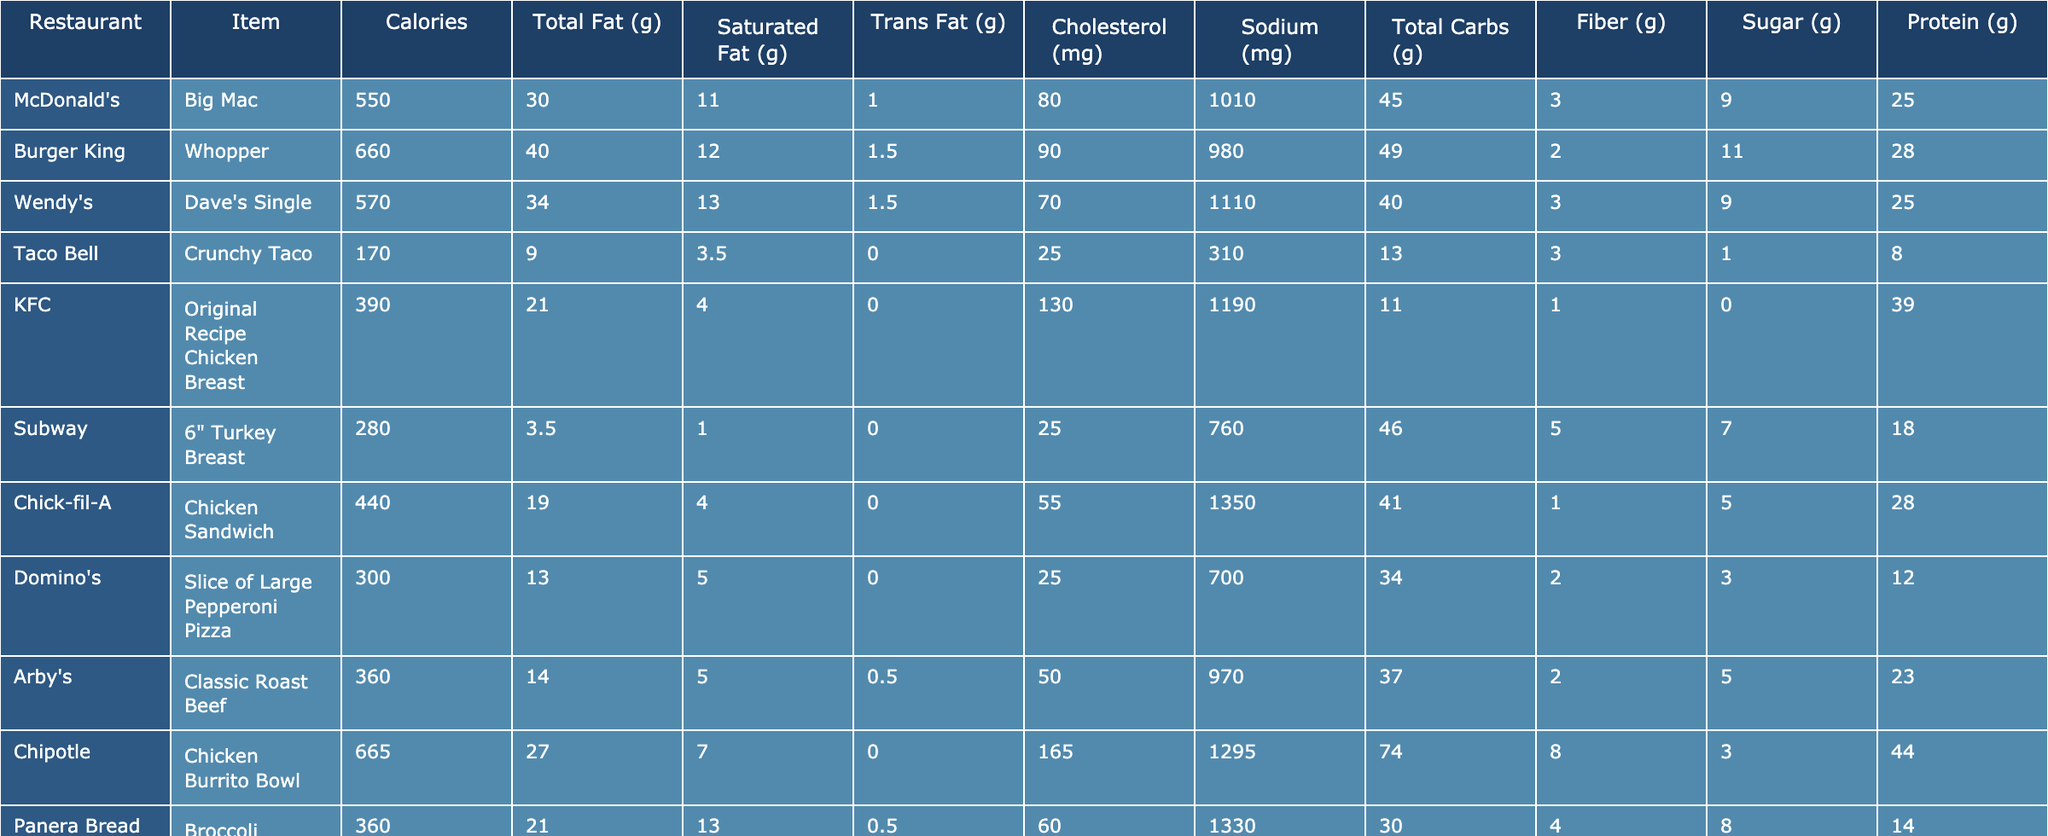What is the calorie content of the Big Mac? The table lists the calorie content specifically for the Big Mac as 550 calories.
Answer: 550 calories Which item has the highest total fat content? By comparing the total fat values in the table, the Five Guys Hamburger has the highest total fat at 55 grams.
Answer: Five Guys Hamburger What is the sodium content in the Chick-fil-A Chicken Sandwich? According to the table, the Chick-fil-A Chicken Sandwich contains 1350 mg of sodium.
Answer: 1350 mg Which fast food item has the lowest calorie count? Looking through the table, the Crunchy Taco from Taco Bell has the lowest calorie count of 170 calories.
Answer: 170 calories What is the difference in protein between the Chicken Burrito Bowl and the Original Recipe Chicken Breast? The Chicken Burrito Bowl has 44 grams of protein, while the Original Recipe Chicken Breast has 39 grams. The difference is 44 - 39 = 5 grams.
Answer: 5 grams True or False: The Whopper contains more total carbs than the Big Mac. The Whopper has 49 grams of total carbs and the Big Mac has 45 grams. Since 49 > 45, the statement is true.
Answer: True What is the average sodium content of all the listed items? Summing the sodium values: 1010 + 980 + 1110 + 310 + 1190 + 760 + 1350 + 700 + 970 + 1295 + 1330 + 330 + 1443 + 1050 = 12228. There are 13 items, so the average is 12228 / 13 ≈ 940.62 mg.
Answer: Approximately 940.62 mg Which item has the most sugar content and how much is it? Reviewing the table, the Caramel Frappuccino has the most sugar at 54 grams.
Answer: Caramel Frappuccino, 54 grams How many fast food items have more than 40 grams of total fat? The items are the Whopper (40 g), Chicken Sandwich (42 g), and Hamburger (55 g). Thus, there are 3 items with more than 40 grams of total fat.
Answer: 3 items Is the fiber content of the Subway 6" Turkey Breast greater than that of the Broccoli Cheddar Soup? The Subway item has 5 grams of fiber, while the Broccoli Cheddar Soup has 4 grams. Since 5 > 4, the statement is true.
Answer: True 